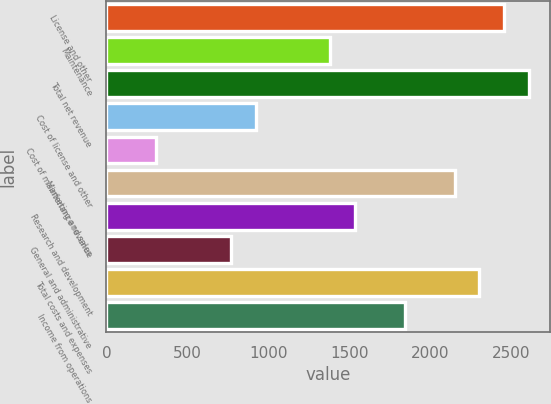Convert chart. <chart><loc_0><loc_0><loc_500><loc_500><bar_chart><fcel>License and other<fcel>Maintenance<fcel>Total net revenue<fcel>Cost of license and other<fcel>Cost of maintenance revenue<fcel>Marketing and sales<fcel>Research and development<fcel>General and administrative<fcel>Total costs and expenses<fcel>Income from operations<nl><fcel>2458.74<fcel>1383.63<fcel>2612.32<fcel>922.88<fcel>308.52<fcel>2151.57<fcel>1537.22<fcel>769.29<fcel>2305.16<fcel>1844.39<nl></chart> 